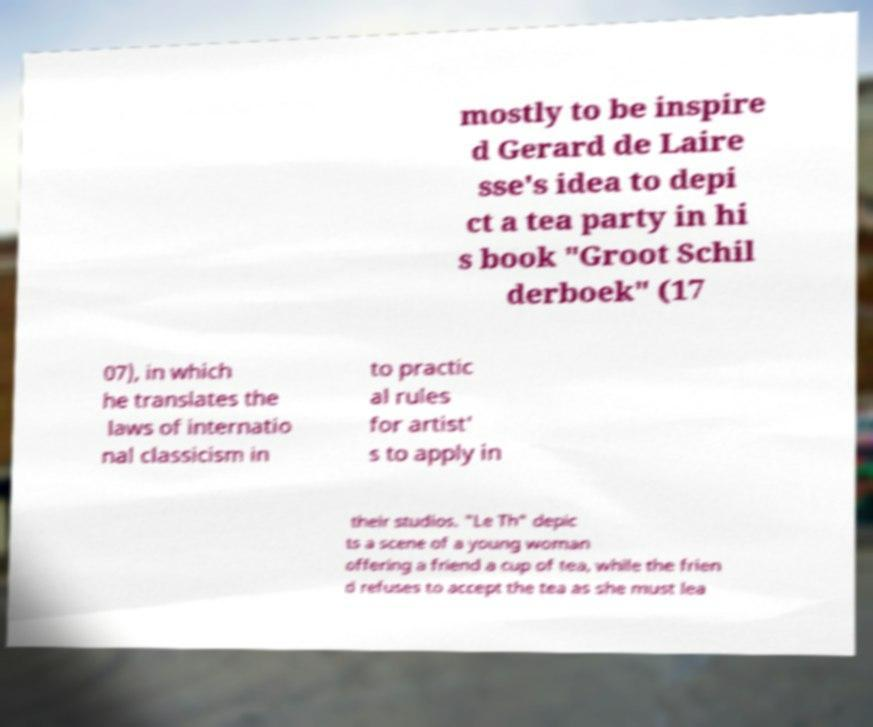Could you extract and type out the text from this image? mostly to be inspire d Gerard de Laire sse's idea to depi ct a tea party in hi s book "Groot Schil derboek" (17 07), in which he translates the laws of internatio nal classicism in to practic al rules for artist' s to apply in their studios. "Le Th" depic ts a scene of a young woman offering a friend a cup of tea, while the frien d refuses to accept the tea as she must lea 